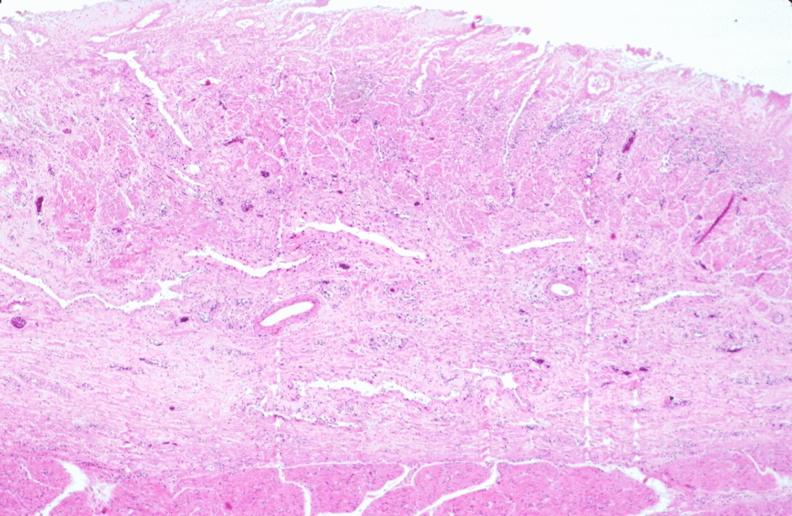what ingested as suicide attempt?
Answer the question using a single word or phrase. Stomach, necrotizing esophagitis and gastritis, sulfuric acid 